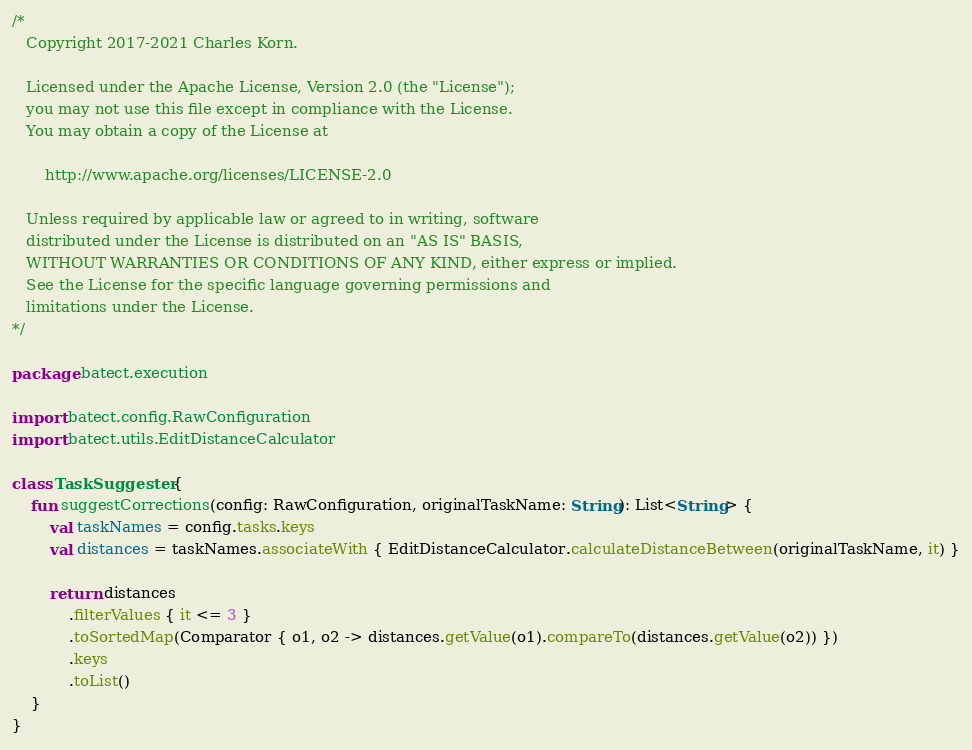<code> <loc_0><loc_0><loc_500><loc_500><_Kotlin_>/*
   Copyright 2017-2021 Charles Korn.

   Licensed under the Apache License, Version 2.0 (the "License");
   you may not use this file except in compliance with the License.
   You may obtain a copy of the License at

       http://www.apache.org/licenses/LICENSE-2.0

   Unless required by applicable law or agreed to in writing, software
   distributed under the License is distributed on an "AS IS" BASIS,
   WITHOUT WARRANTIES OR CONDITIONS OF ANY KIND, either express or implied.
   See the License for the specific language governing permissions and
   limitations under the License.
*/

package batect.execution

import batect.config.RawConfiguration
import batect.utils.EditDistanceCalculator

class TaskSuggester {
    fun suggestCorrections(config: RawConfiguration, originalTaskName: String): List<String> {
        val taskNames = config.tasks.keys
        val distances = taskNames.associateWith { EditDistanceCalculator.calculateDistanceBetween(originalTaskName, it) }

        return distances
            .filterValues { it <= 3 }
            .toSortedMap(Comparator { o1, o2 -> distances.getValue(o1).compareTo(distances.getValue(o2)) })
            .keys
            .toList()
    }
}
</code> 